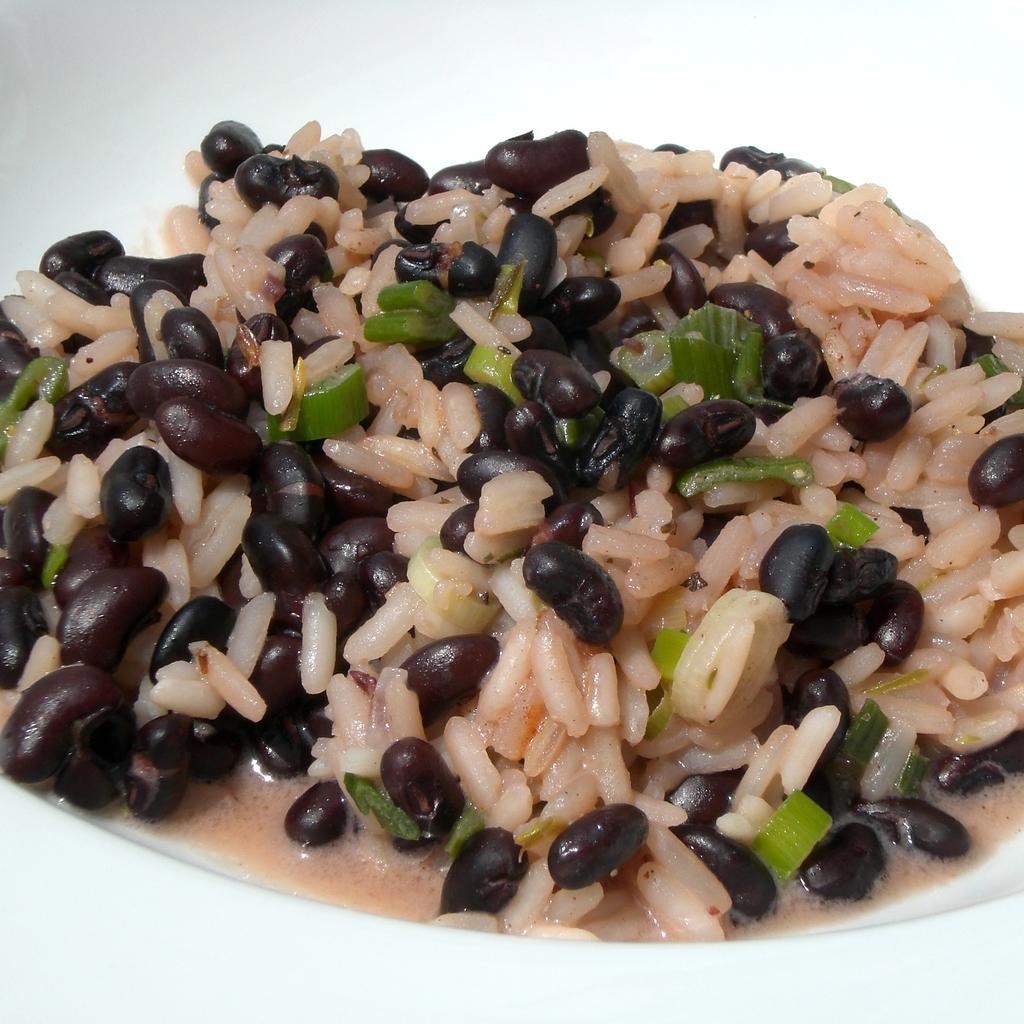How would you summarize this image in a sentence or two? In the picture I can see an edible placed in a white plate. 